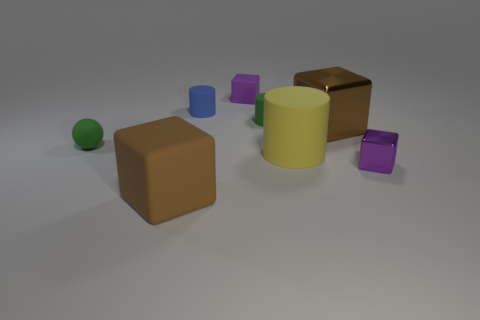Add 2 large blocks. How many objects exist? 10 Subtract all gray blocks. Subtract all gray cylinders. How many blocks are left? 4 Subtract all cylinders. How many objects are left? 5 Subtract all small purple balls. Subtract all small green balls. How many objects are left? 7 Add 2 green rubber cylinders. How many green rubber cylinders are left? 3 Add 6 small purple metallic cubes. How many small purple metallic cubes exist? 7 Subtract 0 red spheres. How many objects are left? 8 